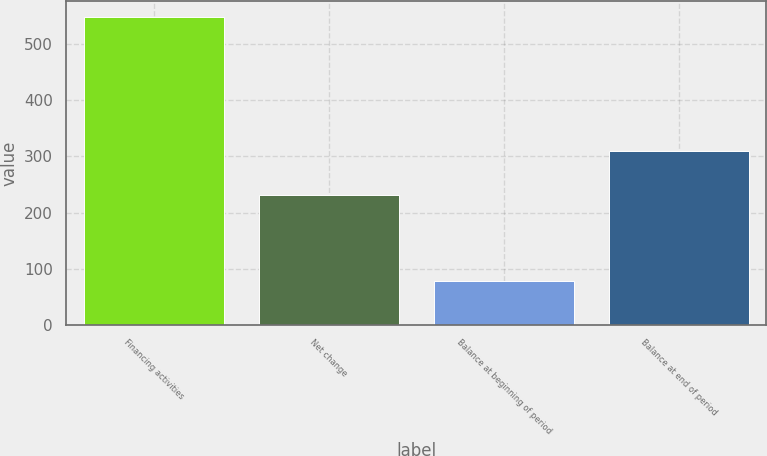Convert chart to OTSL. <chart><loc_0><loc_0><loc_500><loc_500><bar_chart><fcel>Financing activities<fcel>Net change<fcel>Balance at beginning of period<fcel>Balance at end of period<nl><fcel>549<fcel>232<fcel>78<fcel>310<nl></chart> 